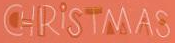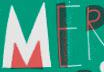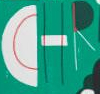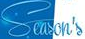Read the text from these images in sequence, separated by a semicolon. CHRİSTMAS; MER; CHR; Season's 